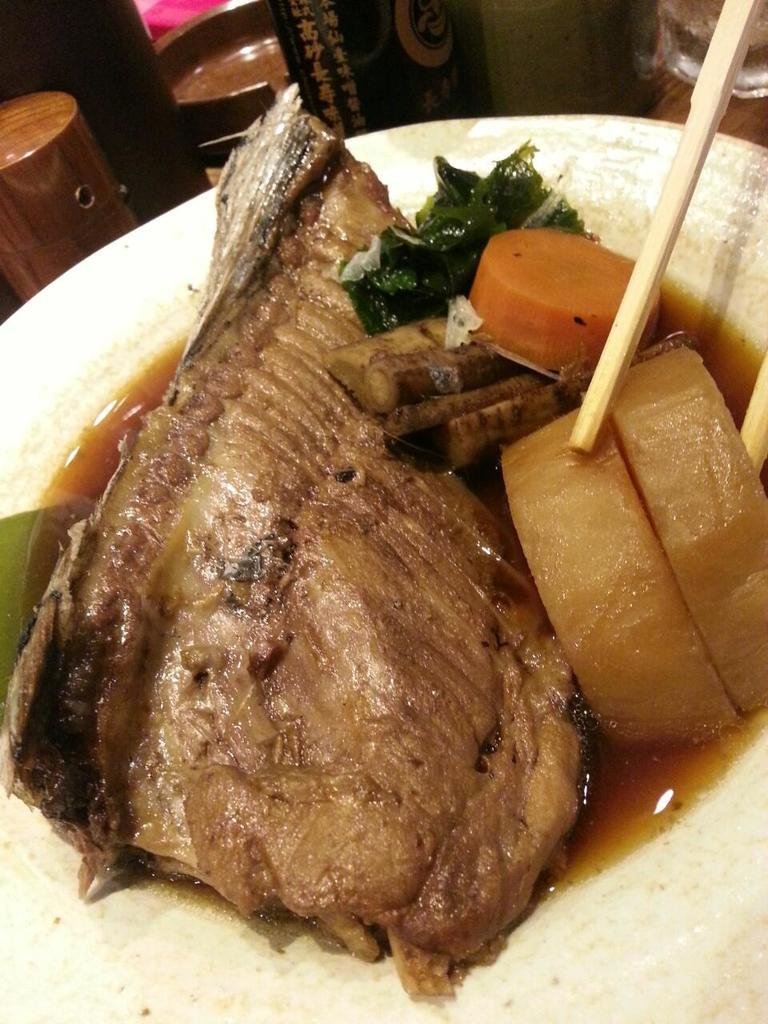What is the main subject of the image? There is a food item in the image. How is the food item presented? The food item is on a white color plate. Where is the plate located in the image? The plate is in the middle of the image. What else can be seen in the image besides the food item? There are objects at the top of the image. What type of whip is being used to prepare the food item in the image? There is no whip present in the image, and the food item does not require preparation with a whip. 